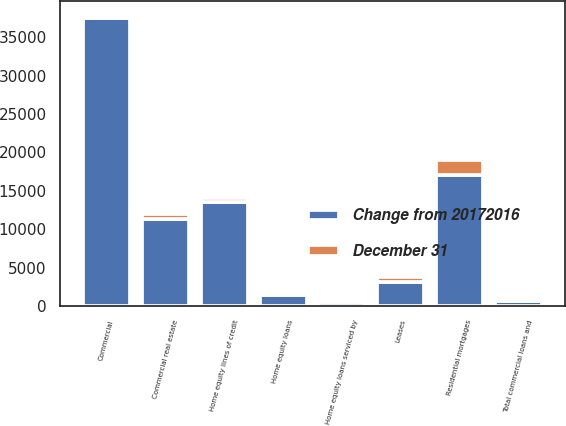<chart> <loc_0><loc_0><loc_500><loc_500><stacked_bar_chart><ecel><fcel>Commercial<fcel>Commercial real estate<fcel>Leases<fcel>Total commercial loans and<fcel>Residential mortgages<fcel>Home equity loans<fcel>Home equity lines of credit<fcel>Home equity loans serviced by<nl><fcel>Change from 20172016<fcel>37562<fcel>11308<fcel>3161<fcel>684<fcel>17045<fcel>1392<fcel>13483<fcel>542<nl><fcel>December 31<fcel>288<fcel>684<fcel>592<fcel>380<fcel>1930<fcel>466<fcel>617<fcel>208<nl></chart> 